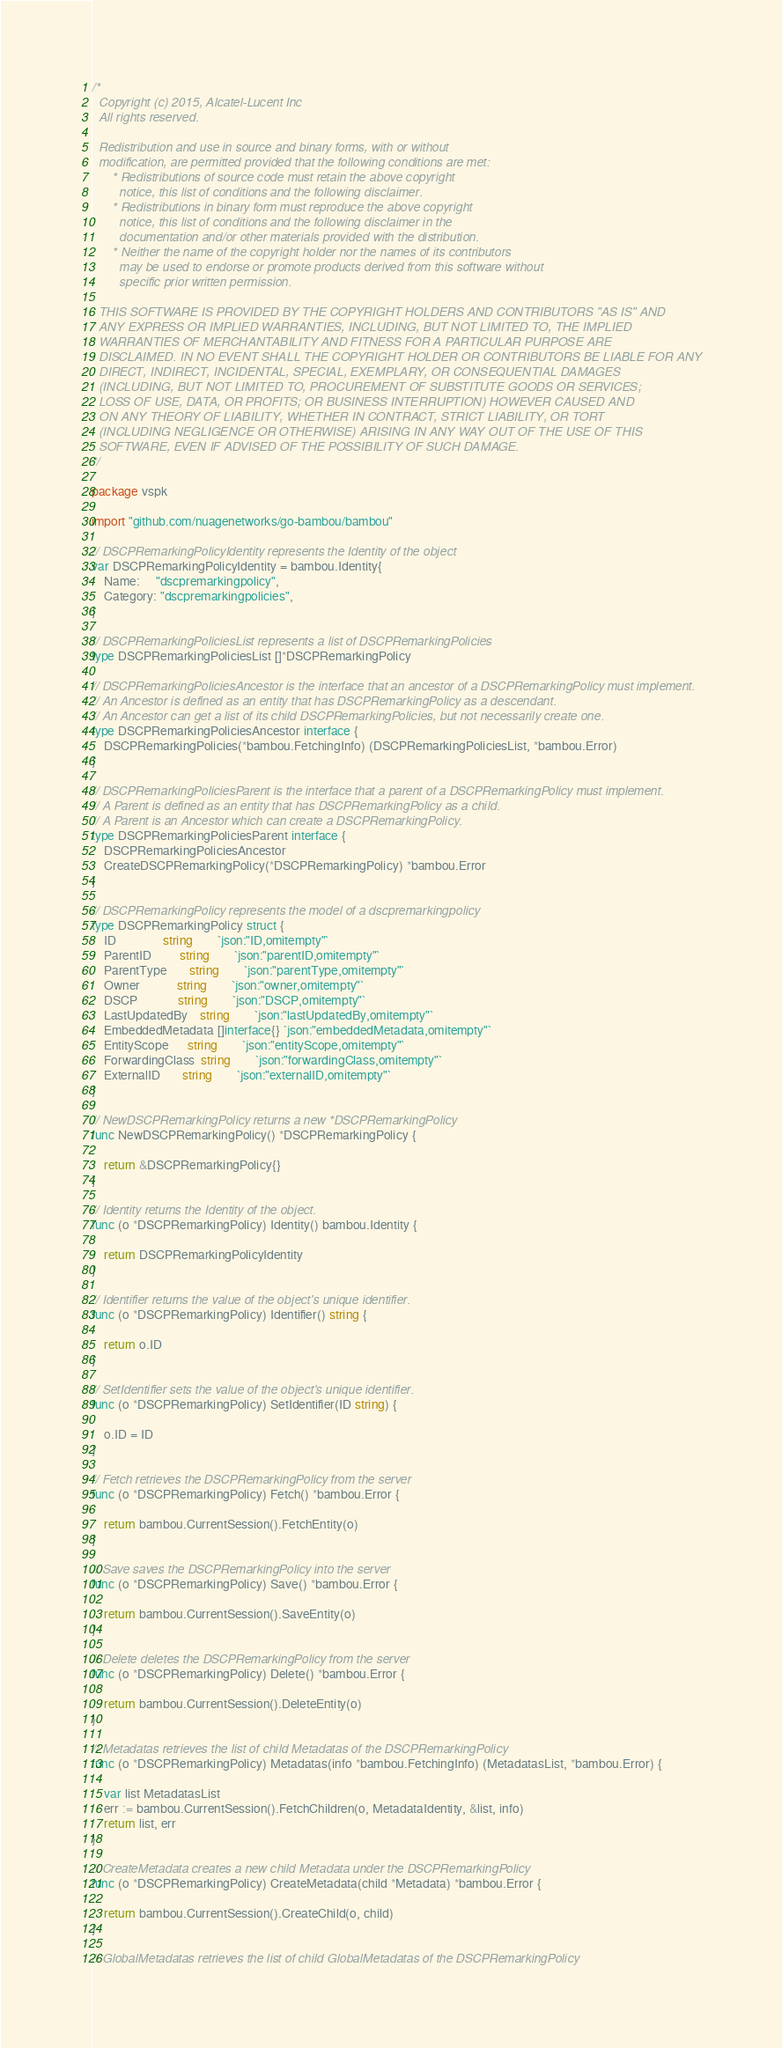Convert code to text. <code><loc_0><loc_0><loc_500><loc_500><_Go_>/*
  Copyright (c) 2015, Alcatel-Lucent Inc
  All rights reserved.

  Redistribution and use in source and binary forms, with or without
  modification, are permitted provided that the following conditions are met:
      * Redistributions of source code must retain the above copyright
        notice, this list of conditions and the following disclaimer.
      * Redistributions in binary form must reproduce the above copyright
        notice, this list of conditions and the following disclaimer in the
        documentation and/or other materials provided with the distribution.
      * Neither the name of the copyright holder nor the names of its contributors
        may be used to endorse or promote products derived from this software without
        specific prior written permission.

  THIS SOFTWARE IS PROVIDED BY THE COPYRIGHT HOLDERS AND CONTRIBUTORS "AS IS" AND
  ANY EXPRESS OR IMPLIED WARRANTIES, INCLUDING, BUT NOT LIMITED TO, THE IMPLIED
  WARRANTIES OF MERCHANTABILITY AND FITNESS FOR A PARTICULAR PURPOSE ARE
  DISCLAIMED. IN NO EVENT SHALL THE COPYRIGHT HOLDER OR CONTRIBUTORS BE LIABLE FOR ANY
  DIRECT, INDIRECT, INCIDENTAL, SPECIAL, EXEMPLARY, OR CONSEQUENTIAL DAMAGES
  (INCLUDING, BUT NOT LIMITED TO, PROCUREMENT OF SUBSTITUTE GOODS OR SERVICES;
  LOSS OF USE, DATA, OR PROFITS; OR BUSINESS INTERRUPTION) HOWEVER CAUSED AND
  ON ANY THEORY OF LIABILITY, WHETHER IN CONTRACT, STRICT LIABILITY, OR TORT
  (INCLUDING NEGLIGENCE OR OTHERWISE) ARISING IN ANY WAY OUT OF THE USE OF THIS
  SOFTWARE, EVEN IF ADVISED OF THE POSSIBILITY OF SUCH DAMAGE.
*/

package vspk

import "github.com/nuagenetworks/go-bambou/bambou"

// DSCPRemarkingPolicyIdentity represents the Identity of the object
var DSCPRemarkingPolicyIdentity = bambou.Identity{
	Name:     "dscpremarkingpolicy",
	Category: "dscpremarkingpolicies",
}

// DSCPRemarkingPoliciesList represents a list of DSCPRemarkingPolicies
type DSCPRemarkingPoliciesList []*DSCPRemarkingPolicy

// DSCPRemarkingPoliciesAncestor is the interface that an ancestor of a DSCPRemarkingPolicy must implement.
// An Ancestor is defined as an entity that has DSCPRemarkingPolicy as a descendant.
// An Ancestor can get a list of its child DSCPRemarkingPolicies, but not necessarily create one.
type DSCPRemarkingPoliciesAncestor interface {
	DSCPRemarkingPolicies(*bambou.FetchingInfo) (DSCPRemarkingPoliciesList, *bambou.Error)
}

// DSCPRemarkingPoliciesParent is the interface that a parent of a DSCPRemarkingPolicy must implement.
// A Parent is defined as an entity that has DSCPRemarkingPolicy as a child.
// A Parent is an Ancestor which can create a DSCPRemarkingPolicy.
type DSCPRemarkingPoliciesParent interface {
	DSCPRemarkingPoliciesAncestor
	CreateDSCPRemarkingPolicy(*DSCPRemarkingPolicy) *bambou.Error
}

// DSCPRemarkingPolicy represents the model of a dscpremarkingpolicy
type DSCPRemarkingPolicy struct {
	ID               string        `json:"ID,omitempty"`
	ParentID         string        `json:"parentID,omitempty"`
	ParentType       string        `json:"parentType,omitempty"`
	Owner            string        `json:"owner,omitempty"`
	DSCP             string        `json:"DSCP,omitempty"`
	LastUpdatedBy    string        `json:"lastUpdatedBy,omitempty"`
	EmbeddedMetadata []interface{} `json:"embeddedMetadata,omitempty"`
	EntityScope      string        `json:"entityScope,omitempty"`
	ForwardingClass  string        `json:"forwardingClass,omitempty"`
	ExternalID       string        `json:"externalID,omitempty"`
}

// NewDSCPRemarkingPolicy returns a new *DSCPRemarkingPolicy
func NewDSCPRemarkingPolicy() *DSCPRemarkingPolicy {

	return &DSCPRemarkingPolicy{}
}

// Identity returns the Identity of the object.
func (o *DSCPRemarkingPolicy) Identity() bambou.Identity {

	return DSCPRemarkingPolicyIdentity
}

// Identifier returns the value of the object's unique identifier.
func (o *DSCPRemarkingPolicy) Identifier() string {

	return o.ID
}

// SetIdentifier sets the value of the object's unique identifier.
func (o *DSCPRemarkingPolicy) SetIdentifier(ID string) {

	o.ID = ID
}

// Fetch retrieves the DSCPRemarkingPolicy from the server
func (o *DSCPRemarkingPolicy) Fetch() *bambou.Error {

	return bambou.CurrentSession().FetchEntity(o)
}

// Save saves the DSCPRemarkingPolicy into the server
func (o *DSCPRemarkingPolicy) Save() *bambou.Error {

	return bambou.CurrentSession().SaveEntity(o)
}

// Delete deletes the DSCPRemarkingPolicy from the server
func (o *DSCPRemarkingPolicy) Delete() *bambou.Error {

	return bambou.CurrentSession().DeleteEntity(o)
}

// Metadatas retrieves the list of child Metadatas of the DSCPRemarkingPolicy
func (o *DSCPRemarkingPolicy) Metadatas(info *bambou.FetchingInfo) (MetadatasList, *bambou.Error) {

	var list MetadatasList
	err := bambou.CurrentSession().FetchChildren(o, MetadataIdentity, &list, info)
	return list, err
}

// CreateMetadata creates a new child Metadata under the DSCPRemarkingPolicy
func (o *DSCPRemarkingPolicy) CreateMetadata(child *Metadata) *bambou.Error {

	return bambou.CurrentSession().CreateChild(o, child)
}

// GlobalMetadatas retrieves the list of child GlobalMetadatas of the DSCPRemarkingPolicy</code> 